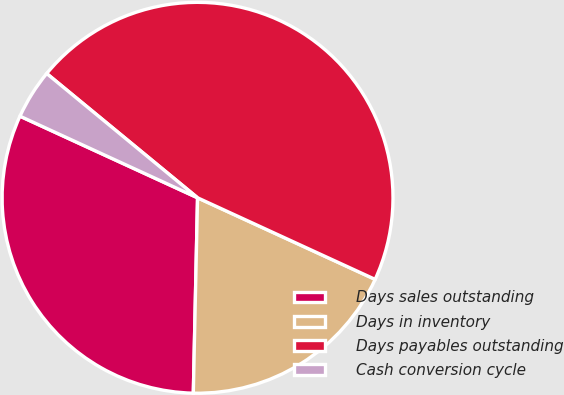Convert chart to OTSL. <chart><loc_0><loc_0><loc_500><loc_500><pie_chart><fcel>Days sales outstanding<fcel>Days in inventory<fcel>Days payables outstanding<fcel>Cash conversion cycle<nl><fcel>31.51%<fcel>18.49%<fcel>45.89%<fcel>4.11%<nl></chart> 